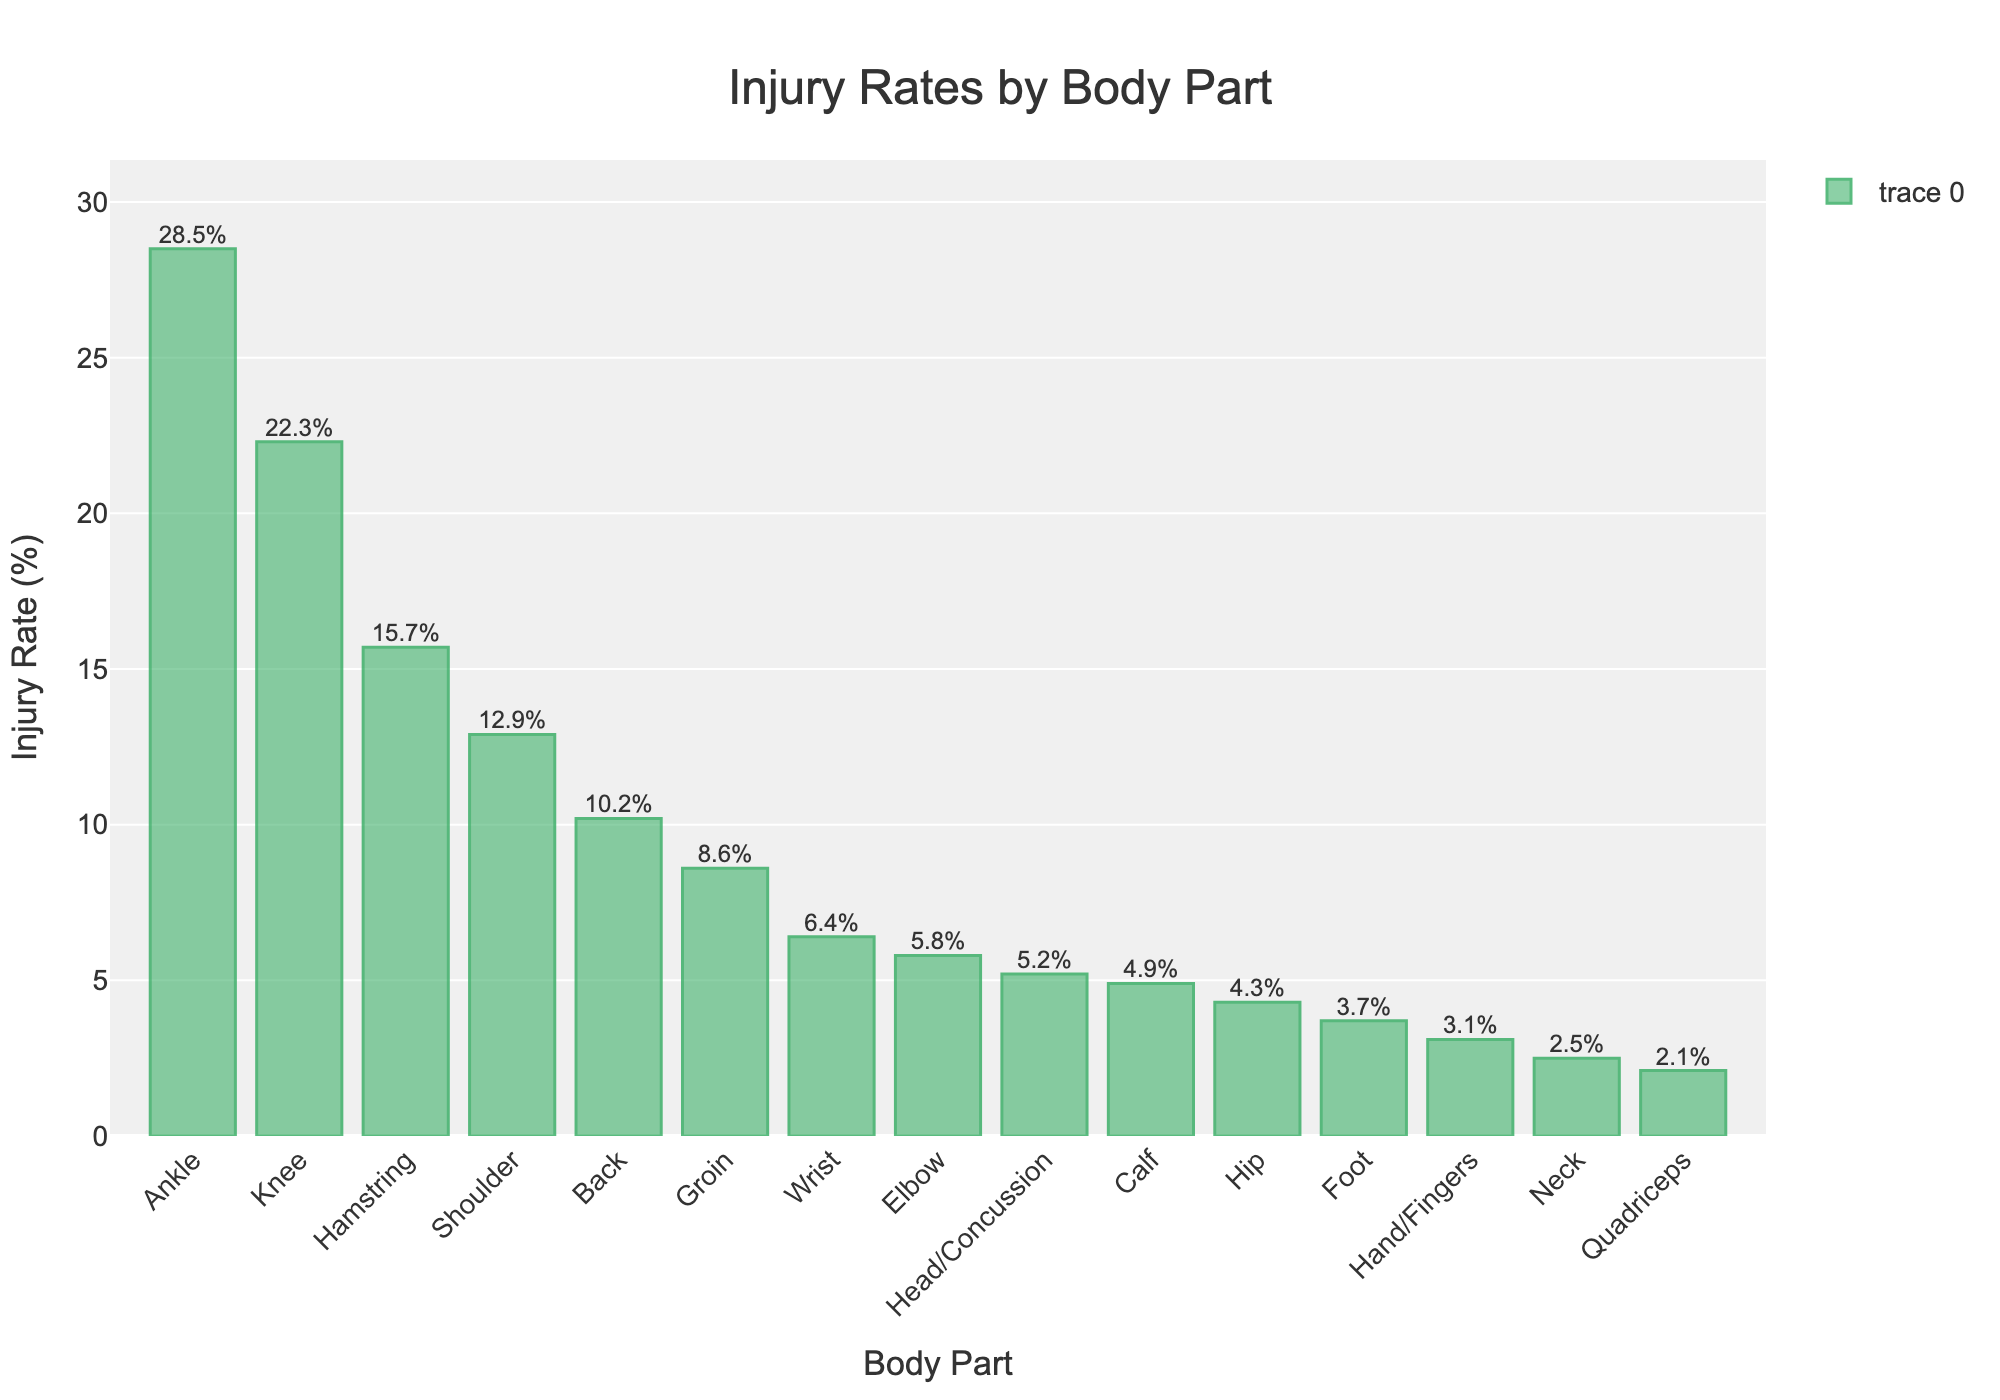Which body part has the highest injury rate? The highest bar in the chart corresponds to the ankle, with an injury rate of 28.5%.
Answer: Ankle What's the combined injury rate of the knee and hamstring? From the chart, the injury rate for the knee is 22.3%, and for the hamstring is 15.7%. Adding them together gives 22.3% + 15.7% = 38%.
Answer: 38% Which has a higher injury rate, the shoulder or the back? By comparing the heights of the bars, the shoulder has an injury rate of 12.9%, whereas the back has an injury rate of 10.2%.
Answer: Shoulder What is the difference in injury rates between the groin and wrist? The chart shows the injury rate for the groin is 8.6% and for the wrist is 6.4%. The difference is 8.6% - 6.4% = 2.2%.
Answer: 2.2% Which body part has the lowest injury rate, and what is that rate? The smallest bar on the chart corresponds to the quadriceps, with an injury rate of 2.1%.
Answer: Quadriceps, 2.1% What's the average injury rate for the head/concussion, calf, and hip? The injury rates are 5.2% for head/concussion, 4.9% for calf, and 4.3% for hip. The average is calculated as (5.2% + 4.9% + 4.3%) / 3 = 4.8%.
Answer: 4.8% How does the injury rate for the ankle compare to the foot? The injury rate for the ankle is 28.5%, while the foot has an injury rate of 3.7%. The ankle's injury rate is significantly higher.
Answer: Ankle is higher Is the wrist or the elbow injury rate closer to the head/concussion injury rate? The wrist has an injury rate of 6.4%, the elbow has 5.8%, and the head/concussion has 5.2%. The elbow's injury rate is closer to the head/concussion.
Answer: Elbow How much higher is the injury rate for the hamstring compared to the hip? The chart shows the hamstring has an injury rate of 15.7%, and the hip has 4.3%. The difference is 15.7% - 4.3% = 11.4%.
Answer: 11.4% What is the total injury rate for the three body parts with the lowest injury rates? From the chart, the three body parts with the lowest rates are neck (2.5%), quadriceps (2.1%), and hand/fingers (3.1%). Their total is 2.5% + 2.1% + 3.1% = 7.7%.
Answer: 7.7% 